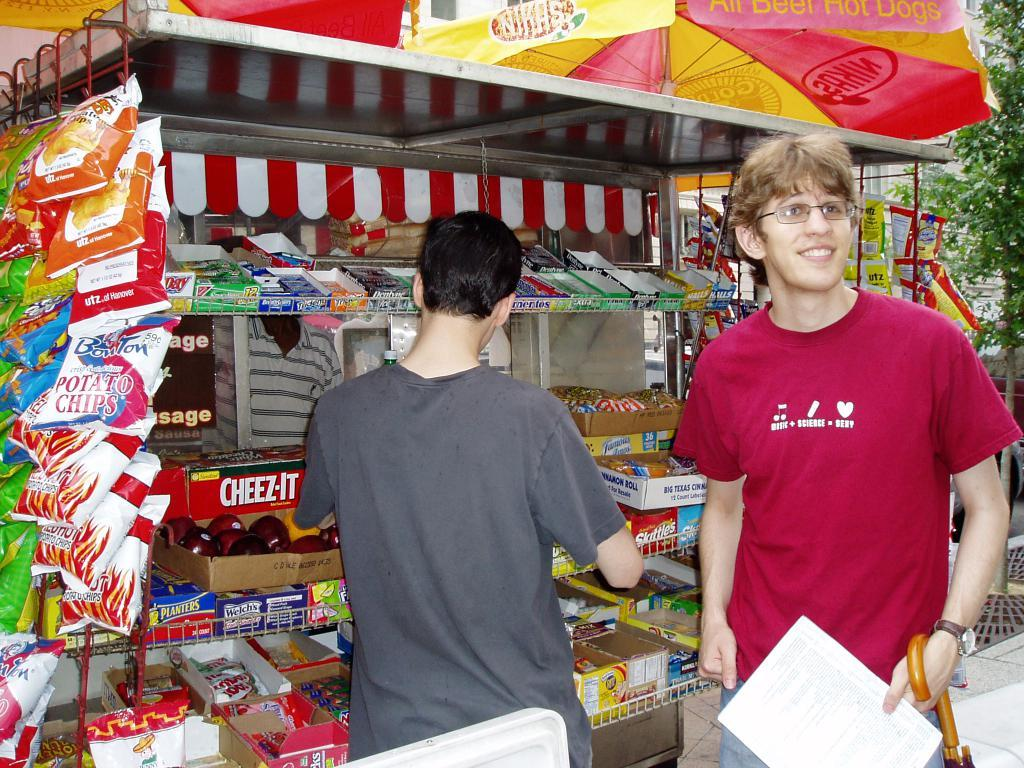<image>
Describe the image concisely. A man with a shirt saying music and science is sexy 